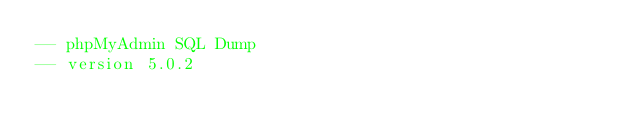Convert code to text. <code><loc_0><loc_0><loc_500><loc_500><_SQL_>-- phpMyAdmin SQL Dump
-- version 5.0.2</code> 